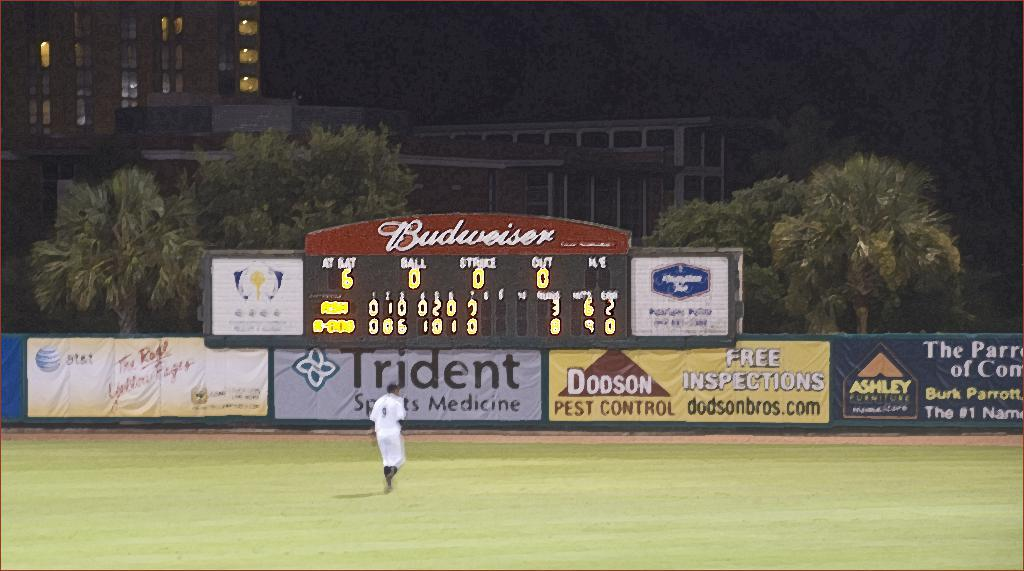<image>
Provide a brief description of the given image. a baseball field score board above ads for things like Trident and Dodson 